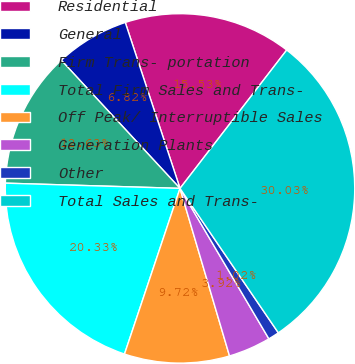Convert chart. <chart><loc_0><loc_0><loc_500><loc_500><pie_chart><fcel>Residential<fcel>General<fcel>Firm Trans- portation<fcel>Total Firm Sales and Trans-<fcel>Off Peak/ Interruptible Sales<fcel>Generation Plants<fcel>Other<fcel>Total Sales and Trans-<nl><fcel>15.53%<fcel>6.82%<fcel>12.63%<fcel>20.33%<fcel>9.72%<fcel>3.92%<fcel>1.02%<fcel>30.03%<nl></chart> 